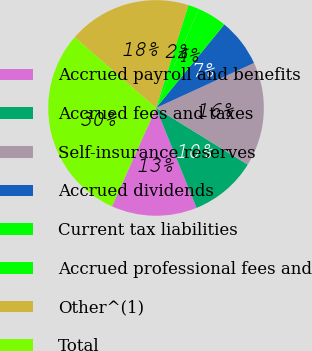Convert chart. <chart><loc_0><loc_0><loc_500><loc_500><pie_chart><fcel>Accrued payroll and benefits<fcel>Accrued fees and taxes<fcel>Self-insurance reserves<fcel>Accrued dividends<fcel>Current tax liabilities<fcel>Accrued professional fees and<fcel>Other^(1)<fcel>Total<nl><fcel>12.85%<fcel>10.05%<fcel>15.66%<fcel>7.24%<fcel>4.43%<fcel>1.63%<fcel>18.46%<fcel>29.68%<nl></chart> 